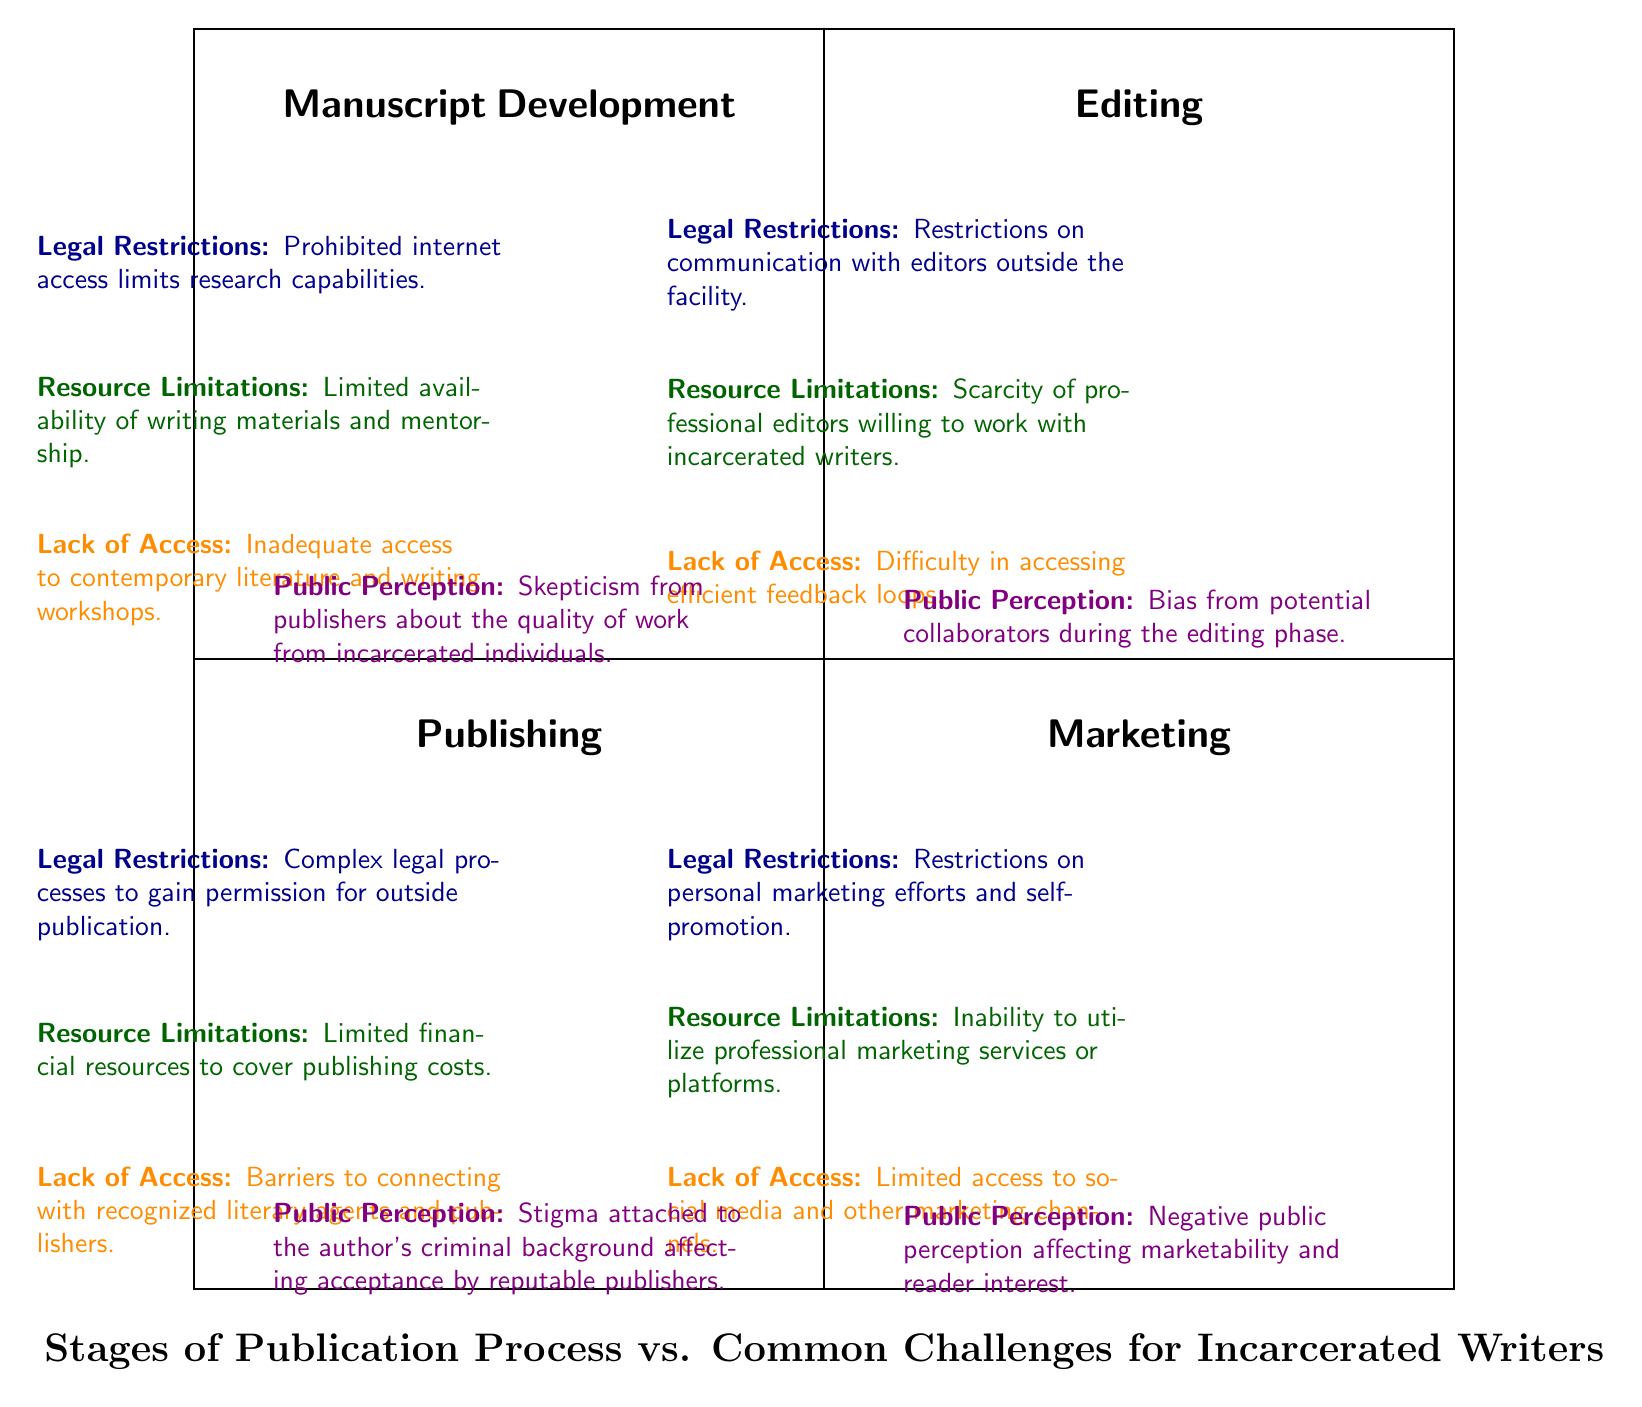What are the four main stages of the publication process listed in the diagram? The diagram clearly identifies four main stages: Manuscript Development, Editing, Publishing, and Marketing, outlined in the quadrants.
Answer: Manuscript Development, Editing, Publishing, Marketing What challenge is associated with the Editing stage concerning resource limitations? The diagram indicates that the challenge under Editing related to resource limitations is the scarcity of professional editors willing to work with incarcerated writers.
Answer: Scarcity of professional editors What type of challenge affects both the Publishing stage and the Marketing stage regarding legal restrictions? Both stages are affected by the challenge of restrictions on personal marketing efforts and self-promotion at the Marketing phase, and complex legal processes to gain permission for outside publication in Publishing.
Answer: Restrictions on personal marketing efforts How many challenges related to Lack of Access are listed in the diagram? There are three distinct occurrences of challenges related to Lack of Access within the four stages, as seen in each relevant quadrant.
Answer: Three What does the Public Perception challenge indicate for the Manuscript Development stage? In the Manuscript Development stage, the Public Perception challenge indicates skepticism from publishers about the quality of work from incarcerated individuals, which may adversely affect their work's acceptance.
Answer: Skepticism from publishers about the quality of work In which quadrant does the challenge of "Limited access to social media and other marketing channels" appear? This challenge is listed in the Marketing quadrant of the diagram, specifically portraying the lack of access affecting marketing efforts for incarcerated writers.
Answer: Marketing quadrant Which stage experiences a challenge with the bias from potential collaborators? The challenge related to bias from potential collaborators is found in the Editing stage, illustrating a significant disadvantage for incarcerated writers at this point in the publication process.
Answer: Editing stage How does the challenge of resource limitations affect the Publishing stage? The challenge of resource limitations in the Publishing stage is characterized by limited financial resources to cover publishing costs, restricting the writer's ability to publish their work effectively.
Answer: Limited financial resources to cover publishing costs 